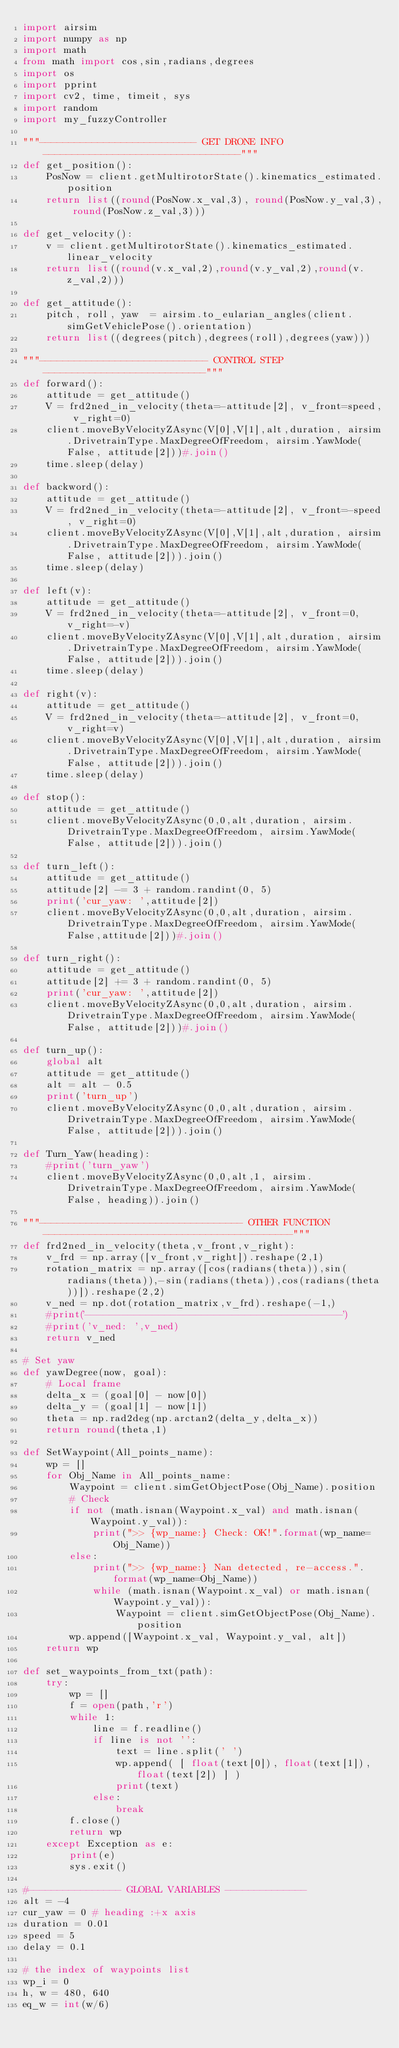Convert code to text. <code><loc_0><loc_0><loc_500><loc_500><_Python_>import airsim
import numpy as np
import math
from math import cos,sin,radians,degrees
import os
import pprint
import cv2, time, timeit, sys
import random
import my_fuzzyController

"""--------------------------- GET DRONE INFO ----------------------------------"""
def get_position():
    PosNow = client.getMultirotorState().kinematics_estimated.position
    return list((round(PosNow.x_val,3), round(PosNow.y_val,3), round(PosNow.z_val,3)))

def get_velocity():
    v = client.getMultirotorState().kinematics_estimated.linear_velocity
    return list((round(v.x_val,2),round(v.y_val,2),round(v.z_val,2)))

def get_attitude():
    pitch, roll, yaw  = airsim.to_eularian_angles(client.simGetVehiclePose().orientation)
    return list((degrees(pitch),degrees(roll),degrees(yaw)))

"""----------------------------- CONTROL STEP ----------------------------"""
def forward():                
    attitude = get_attitude()          
    V = frd2ned_in_velocity(theta=-attitude[2], v_front=speed, v_right=0) 
    client.moveByVelocityZAsync(V[0],V[1],alt,duration, airsim.DrivetrainType.MaxDegreeOfFreedom, airsim.YawMode(False, attitude[2]))#.join()
    time.sleep(delay)

def backword():              
    attitude = get_attitude()                  
    V = frd2ned_in_velocity(theta=-attitude[2], v_front=-speed, v_right=0) 
    client.moveByVelocityZAsync(V[0],V[1],alt,duration, airsim.DrivetrainType.MaxDegreeOfFreedom, airsim.YawMode(False, attitude[2])).join()
    time.sleep(delay)

def left(v):                     
    attitude = get_attitude()            
    V = frd2ned_in_velocity(theta=-attitude[2], v_front=0, v_right=-v) 
    client.moveByVelocityZAsync(V[0],V[1],alt,duration, airsim.DrivetrainType.MaxDegreeOfFreedom, airsim.YawMode(False, attitude[2])).join()
    time.sleep(delay)

def right(v):               
    attitude = get_attitude()                      
    V = frd2ned_in_velocity(theta=-attitude[2], v_front=0, v_right=v) 
    client.moveByVelocityZAsync(V[0],V[1],alt,duration, airsim.DrivetrainType.MaxDegreeOfFreedom, airsim.YawMode(False, attitude[2])).join()
    time.sleep(delay)

def stop():                  
    attitude = get_attitude()        
    client.moveByVelocityZAsync(0,0,alt,duration, airsim.DrivetrainType.MaxDegreeOfFreedom, airsim.YawMode(False, attitude[2])).join()            

def turn_left():       
    attitude = get_attitude()
    attitude[2] -= 3 + random.randint(0, 5)
    print('cur_yaw: ',attitude[2])
    client.moveByVelocityZAsync(0,0,alt,duration, airsim.DrivetrainType.MaxDegreeOfFreedom, airsim.YawMode(False,attitude[2]))#.join()  

def turn_right():       
    attitude = get_attitude()
    attitude[2] += 3 + random.randint(0, 5)     
    print('cur_yaw: ',attitude[2])   
    client.moveByVelocityZAsync(0,0,alt,duration, airsim.DrivetrainType.MaxDegreeOfFreedom, airsim.YawMode(False, attitude[2]))#.join() 

def turn_up():    
    global alt    
    attitude = get_attitude()    
    alt = alt - 0.5
    print('turn_up')
    client.moveByVelocityZAsync(0,0,alt,duration, airsim.DrivetrainType.MaxDegreeOfFreedom, airsim.YawMode(False, attitude[2])).join()  

def Turn_Yaw(heading):
    #print('turn_yaw')
    client.moveByVelocityZAsync(0,0,alt,1, airsim.DrivetrainType.MaxDegreeOfFreedom, airsim.YawMode(False, heading)).join()  

"""----------------------------------- OTHER FUNCTION -------------------------------------------"""
def frd2ned_in_velocity(theta,v_front,v_right):       
    v_frd = np.array([v_front,v_right]).reshape(2,1)
    rotation_matrix = np.array([cos(radians(theta)),sin(radians(theta)),-sin(radians(theta)),cos(radians(theta))]).reshape(2,2)
    v_ned = np.dot(rotation_matrix,v_frd).reshape(-1,)
    #print('------------------------------------------')
    #print('v_ned: ',v_ned)
    return v_ned  

# Set yaw
def yawDegree(now, goal):
    # Local frame
    delta_x = (goal[0] - now[0])
    delta_y = (goal[1] - now[1])
    theta = np.rad2deg(np.arctan2(delta_y,delta_x))
    return round(theta,1)

def SetWaypoint(All_points_name):
    wp = []
    for Obj_Name in All_points_name:
        Waypoint = client.simGetObjectPose(Obj_Name).position
        # Check 
        if not (math.isnan(Waypoint.x_val) and math.isnan(Waypoint.y_val)):
            print(">> {wp_name:} Check: OK!".format(wp_name=Obj_Name))
        else:
            print(">> {wp_name:} Nan detected, re-access.".format(wp_name=Obj_Name))
            while (math.isnan(Waypoint.x_val) or math.isnan(Waypoint.y_val)):
                Waypoint = client.simGetObjectPose(Obj_Name).position                        
        wp.append([Waypoint.x_val, Waypoint.y_val, alt])
    return wp

def set_waypoints_from_txt(path):
    try:
        wp = []
        f = open(path,'r')
        while 1:
            line = f.readline()
            if line is not '':            
                text = line.split(' ')
                wp.append( [ float(text[0]), float(text[1]), float(text[2]) ] )
                print(text)
            else:
                break
        f.close()
        return wp
    except Exception as e:
        print(e)
        sys.exit()

#---------------- GLOBAL VARIABLES --------------
alt = -4
cur_yaw = 0 # heading :+x axis
duration = 0.01
speed = 5
delay = 0.1

# the index of waypoints list
wp_i = 0
h, w = 480, 640
eq_w = int(w/6) </code> 